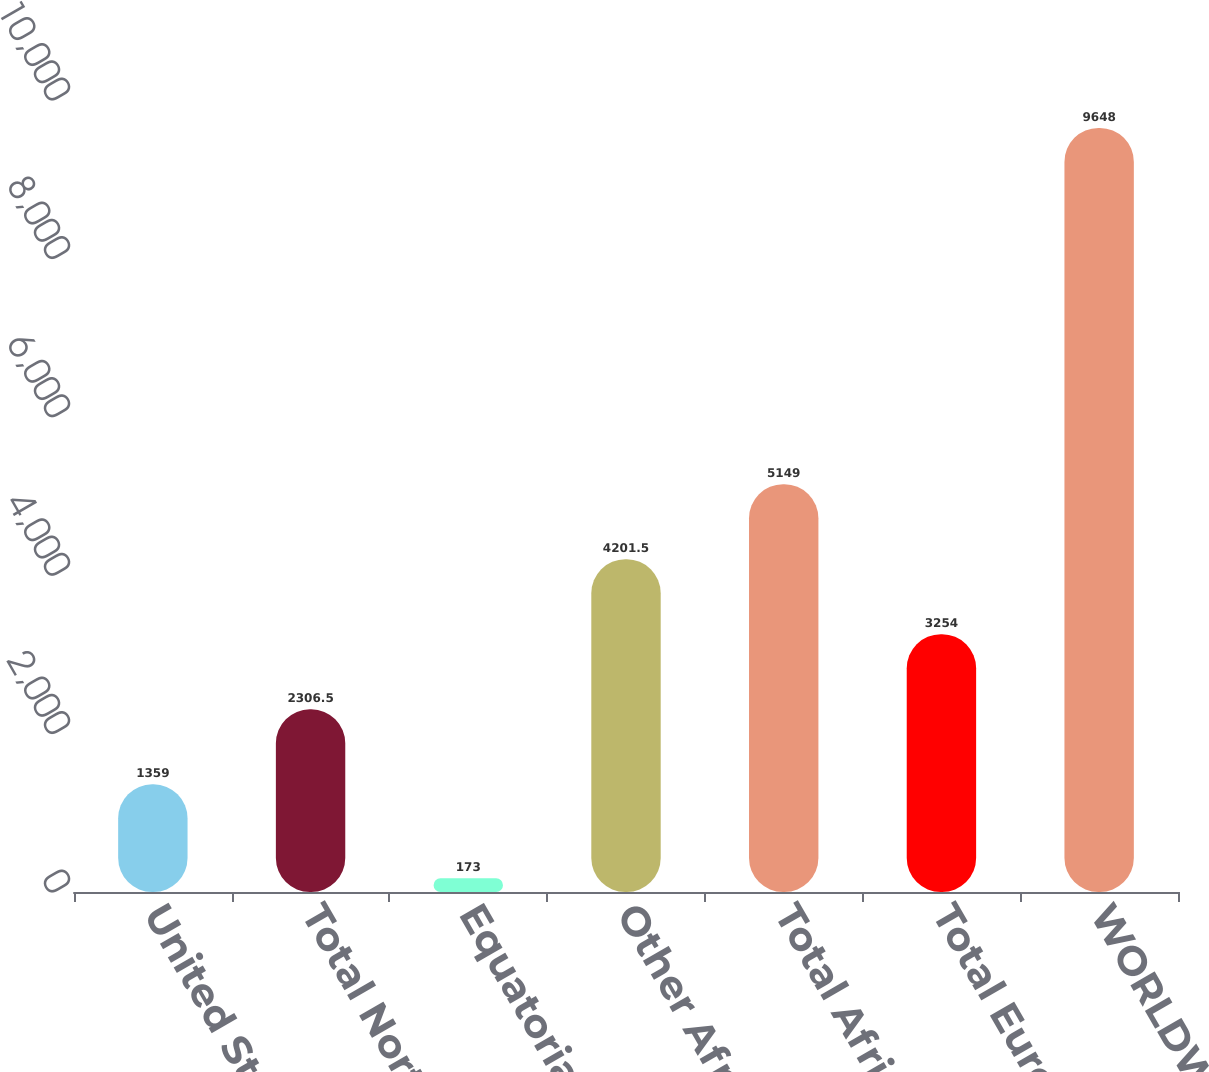Convert chart. <chart><loc_0><loc_0><loc_500><loc_500><bar_chart><fcel>United States<fcel>Total North America<fcel>Equatorial Guinea<fcel>Other Africa<fcel>Total Africa<fcel>Total Europe<fcel>WORLDWIDE<nl><fcel>1359<fcel>2306.5<fcel>173<fcel>4201.5<fcel>5149<fcel>3254<fcel>9648<nl></chart> 